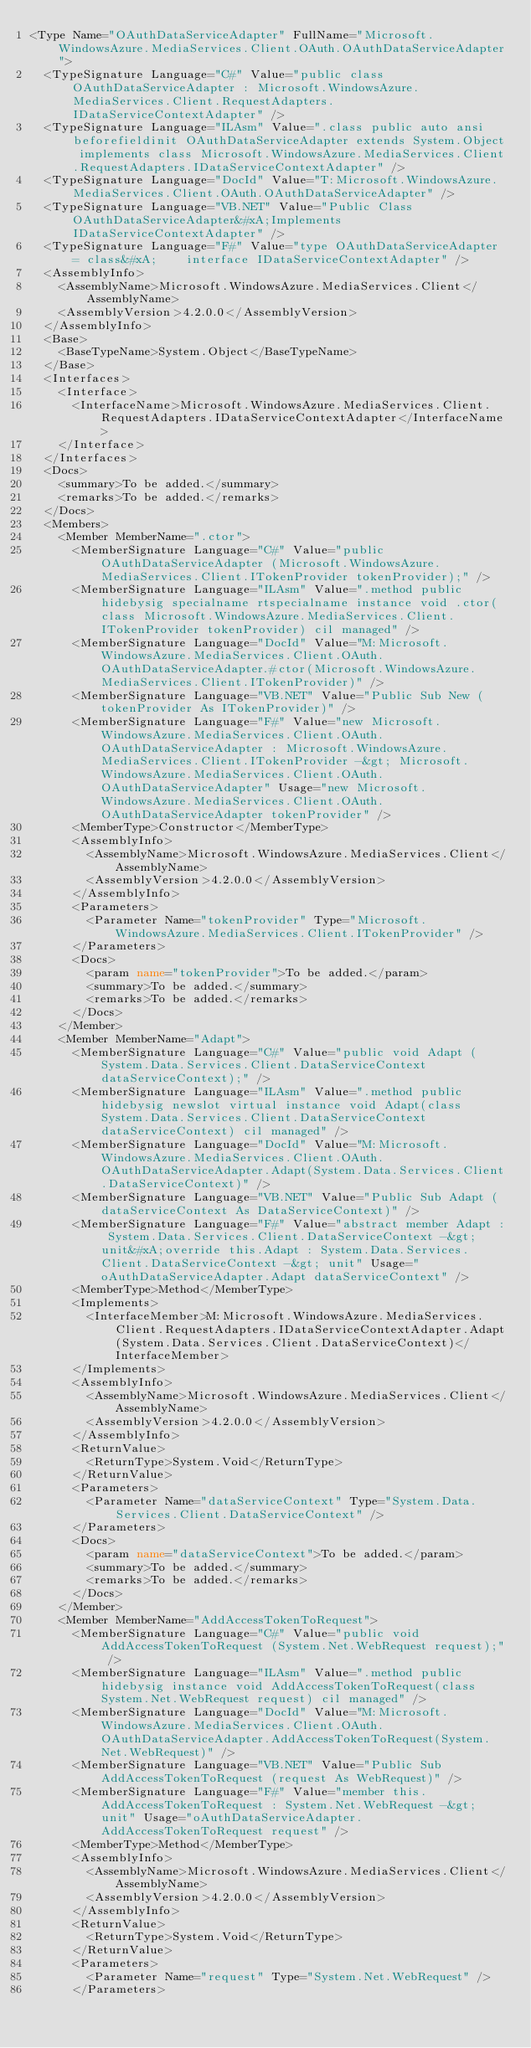<code> <loc_0><loc_0><loc_500><loc_500><_XML_><Type Name="OAuthDataServiceAdapter" FullName="Microsoft.WindowsAzure.MediaServices.Client.OAuth.OAuthDataServiceAdapter">
  <TypeSignature Language="C#" Value="public class OAuthDataServiceAdapter : Microsoft.WindowsAzure.MediaServices.Client.RequestAdapters.IDataServiceContextAdapter" />
  <TypeSignature Language="ILAsm" Value=".class public auto ansi beforefieldinit OAuthDataServiceAdapter extends System.Object implements class Microsoft.WindowsAzure.MediaServices.Client.RequestAdapters.IDataServiceContextAdapter" />
  <TypeSignature Language="DocId" Value="T:Microsoft.WindowsAzure.MediaServices.Client.OAuth.OAuthDataServiceAdapter" />
  <TypeSignature Language="VB.NET" Value="Public Class OAuthDataServiceAdapter&#xA;Implements IDataServiceContextAdapter" />
  <TypeSignature Language="F#" Value="type OAuthDataServiceAdapter = class&#xA;    interface IDataServiceContextAdapter" />
  <AssemblyInfo>
    <AssemblyName>Microsoft.WindowsAzure.MediaServices.Client</AssemblyName>
    <AssemblyVersion>4.2.0.0</AssemblyVersion>
  </AssemblyInfo>
  <Base>
    <BaseTypeName>System.Object</BaseTypeName>
  </Base>
  <Interfaces>
    <Interface>
      <InterfaceName>Microsoft.WindowsAzure.MediaServices.Client.RequestAdapters.IDataServiceContextAdapter</InterfaceName>
    </Interface>
  </Interfaces>
  <Docs>
    <summary>To be added.</summary>
    <remarks>To be added.</remarks>
  </Docs>
  <Members>
    <Member MemberName=".ctor">
      <MemberSignature Language="C#" Value="public OAuthDataServiceAdapter (Microsoft.WindowsAzure.MediaServices.Client.ITokenProvider tokenProvider);" />
      <MemberSignature Language="ILAsm" Value=".method public hidebysig specialname rtspecialname instance void .ctor(class Microsoft.WindowsAzure.MediaServices.Client.ITokenProvider tokenProvider) cil managed" />
      <MemberSignature Language="DocId" Value="M:Microsoft.WindowsAzure.MediaServices.Client.OAuth.OAuthDataServiceAdapter.#ctor(Microsoft.WindowsAzure.MediaServices.Client.ITokenProvider)" />
      <MemberSignature Language="VB.NET" Value="Public Sub New (tokenProvider As ITokenProvider)" />
      <MemberSignature Language="F#" Value="new Microsoft.WindowsAzure.MediaServices.Client.OAuth.OAuthDataServiceAdapter : Microsoft.WindowsAzure.MediaServices.Client.ITokenProvider -&gt; Microsoft.WindowsAzure.MediaServices.Client.OAuth.OAuthDataServiceAdapter" Usage="new Microsoft.WindowsAzure.MediaServices.Client.OAuth.OAuthDataServiceAdapter tokenProvider" />
      <MemberType>Constructor</MemberType>
      <AssemblyInfo>
        <AssemblyName>Microsoft.WindowsAzure.MediaServices.Client</AssemblyName>
        <AssemblyVersion>4.2.0.0</AssemblyVersion>
      </AssemblyInfo>
      <Parameters>
        <Parameter Name="tokenProvider" Type="Microsoft.WindowsAzure.MediaServices.Client.ITokenProvider" />
      </Parameters>
      <Docs>
        <param name="tokenProvider">To be added.</param>
        <summary>To be added.</summary>
        <remarks>To be added.</remarks>
      </Docs>
    </Member>
    <Member MemberName="Adapt">
      <MemberSignature Language="C#" Value="public void Adapt (System.Data.Services.Client.DataServiceContext dataServiceContext);" />
      <MemberSignature Language="ILAsm" Value=".method public hidebysig newslot virtual instance void Adapt(class System.Data.Services.Client.DataServiceContext dataServiceContext) cil managed" />
      <MemberSignature Language="DocId" Value="M:Microsoft.WindowsAzure.MediaServices.Client.OAuth.OAuthDataServiceAdapter.Adapt(System.Data.Services.Client.DataServiceContext)" />
      <MemberSignature Language="VB.NET" Value="Public Sub Adapt (dataServiceContext As DataServiceContext)" />
      <MemberSignature Language="F#" Value="abstract member Adapt : System.Data.Services.Client.DataServiceContext -&gt; unit&#xA;override this.Adapt : System.Data.Services.Client.DataServiceContext -&gt; unit" Usage="oAuthDataServiceAdapter.Adapt dataServiceContext" />
      <MemberType>Method</MemberType>
      <Implements>
        <InterfaceMember>M:Microsoft.WindowsAzure.MediaServices.Client.RequestAdapters.IDataServiceContextAdapter.Adapt(System.Data.Services.Client.DataServiceContext)</InterfaceMember>
      </Implements>
      <AssemblyInfo>
        <AssemblyName>Microsoft.WindowsAzure.MediaServices.Client</AssemblyName>
        <AssemblyVersion>4.2.0.0</AssemblyVersion>
      </AssemblyInfo>
      <ReturnValue>
        <ReturnType>System.Void</ReturnType>
      </ReturnValue>
      <Parameters>
        <Parameter Name="dataServiceContext" Type="System.Data.Services.Client.DataServiceContext" />
      </Parameters>
      <Docs>
        <param name="dataServiceContext">To be added.</param>
        <summary>To be added.</summary>
        <remarks>To be added.</remarks>
      </Docs>
    </Member>
    <Member MemberName="AddAccessTokenToRequest">
      <MemberSignature Language="C#" Value="public void AddAccessTokenToRequest (System.Net.WebRequest request);" />
      <MemberSignature Language="ILAsm" Value=".method public hidebysig instance void AddAccessTokenToRequest(class System.Net.WebRequest request) cil managed" />
      <MemberSignature Language="DocId" Value="M:Microsoft.WindowsAzure.MediaServices.Client.OAuth.OAuthDataServiceAdapter.AddAccessTokenToRequest(System.Net.WebRequest)" />
      <MemberSignature Language="VB.NET" Value="Public Sub AddAccessTokenToRequest (request As WebRequest)" />
      <MemberSignature Language="F#" Value="member this.AddAccessTokenToRequest : System.Net.WebRequest -&gt; unit" Usage="oAuthDataServiceAdapter.AddAccessTokenToRequest request" />
      <MemberType>Method</MemberType>
      <AssemblyInfo>
        <AssemblyName>Microsoft.WindowsAzure.MediaServices.Client</AssemblyName>
        <AssemblyVersion>4.2.0.0</AssemblyVersion>
      </AssemblyInfo>
      <ReturnValue>
        <ReturnType>System.Void</ReturnType>
      </ReturnValue>
      <Parameters>
        <Parameter Name="request" Type="System.Net.WebRequest" />
      </Parameters></code> 